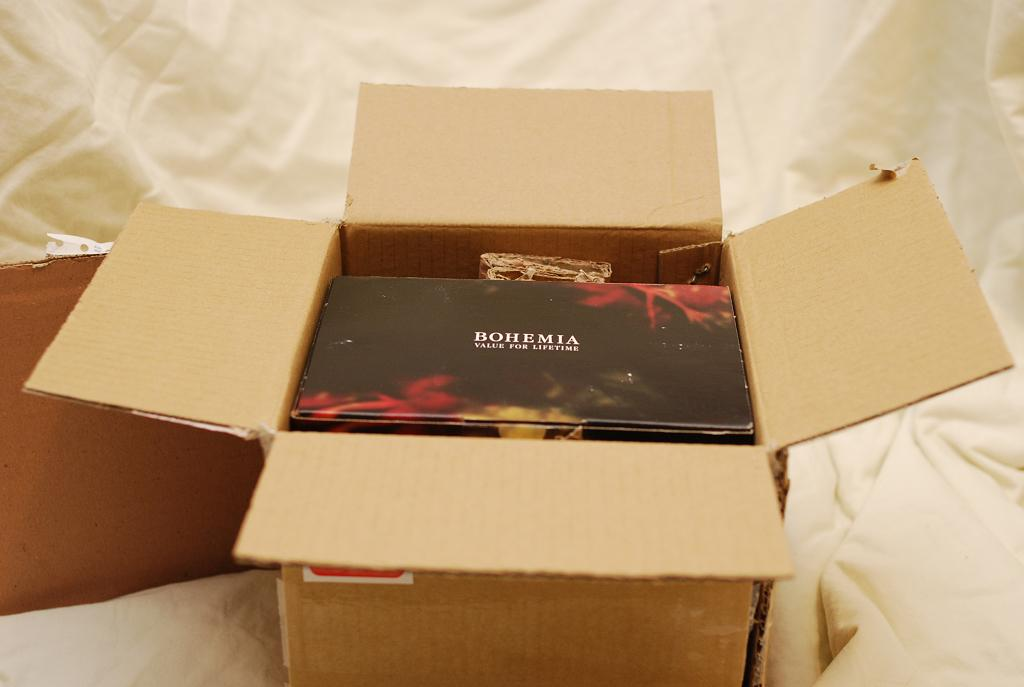<image>
Relay a brief, clear account of the picture shown. the name Bohemia that is on an item 